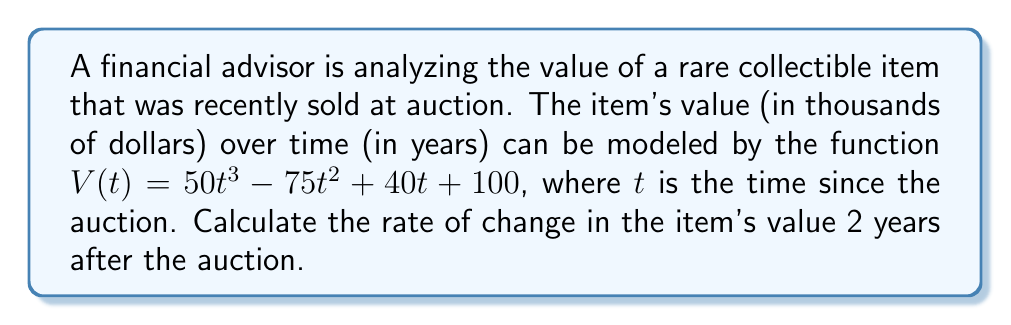Show me your answer to this math problem. To find the rate of change in the item's value at a specific point in time, we need to calculate the derivative of the value function and evaluate it at the given time.

1. Start with the value function:
   $V(t) = 50t^3 - 75t^2 + 40t + 100$

2. Calculate the derivative $V'(t)$ using the power rule and constant rule:
   $V'(t) = 150t^2 - 150t + 40$

3. The question asks for the rate of change 2 years after the auction, so we need to evaluate $V'(2)$:
   $V'(2) = 150(2)^2 - 150(2) + 40$
   $V'(2) = 150(4) - 300 + 40$
   $V'(2) = 600 - 300 + 40$
   $V'(2) = 340$

4. Interpret the result:
   The rate of change is 340 thousand dollars per year, or $340,000 per year.

This positive rate of change indicates that the item's value is increasing rapidly 2 years after the auction, which demonstrates the volatile nature of auction-related assets that the financial advisor warns against.
Answer: $340,000 per year 